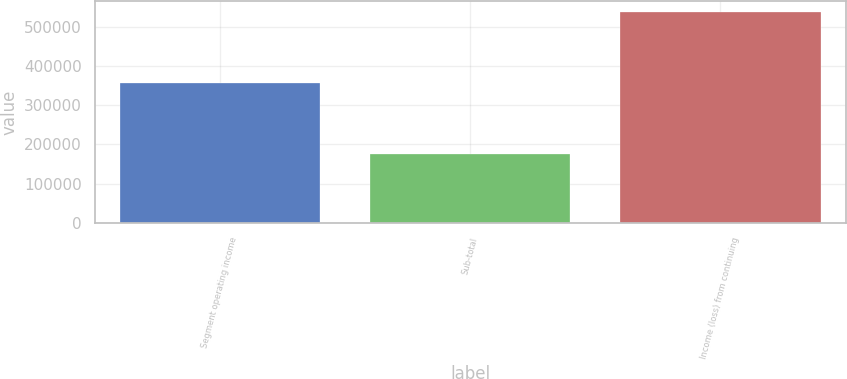Convert chart to OTSL. <chart><loc_0><loc_0><loc_500><loc_500><bar_chart><fcel>Segment operating income<fcel>Sub-total<fcel>Income (loss) from continuing<nl><fcel>357152<fcel>175571<fcel>538728<nl></chart> 